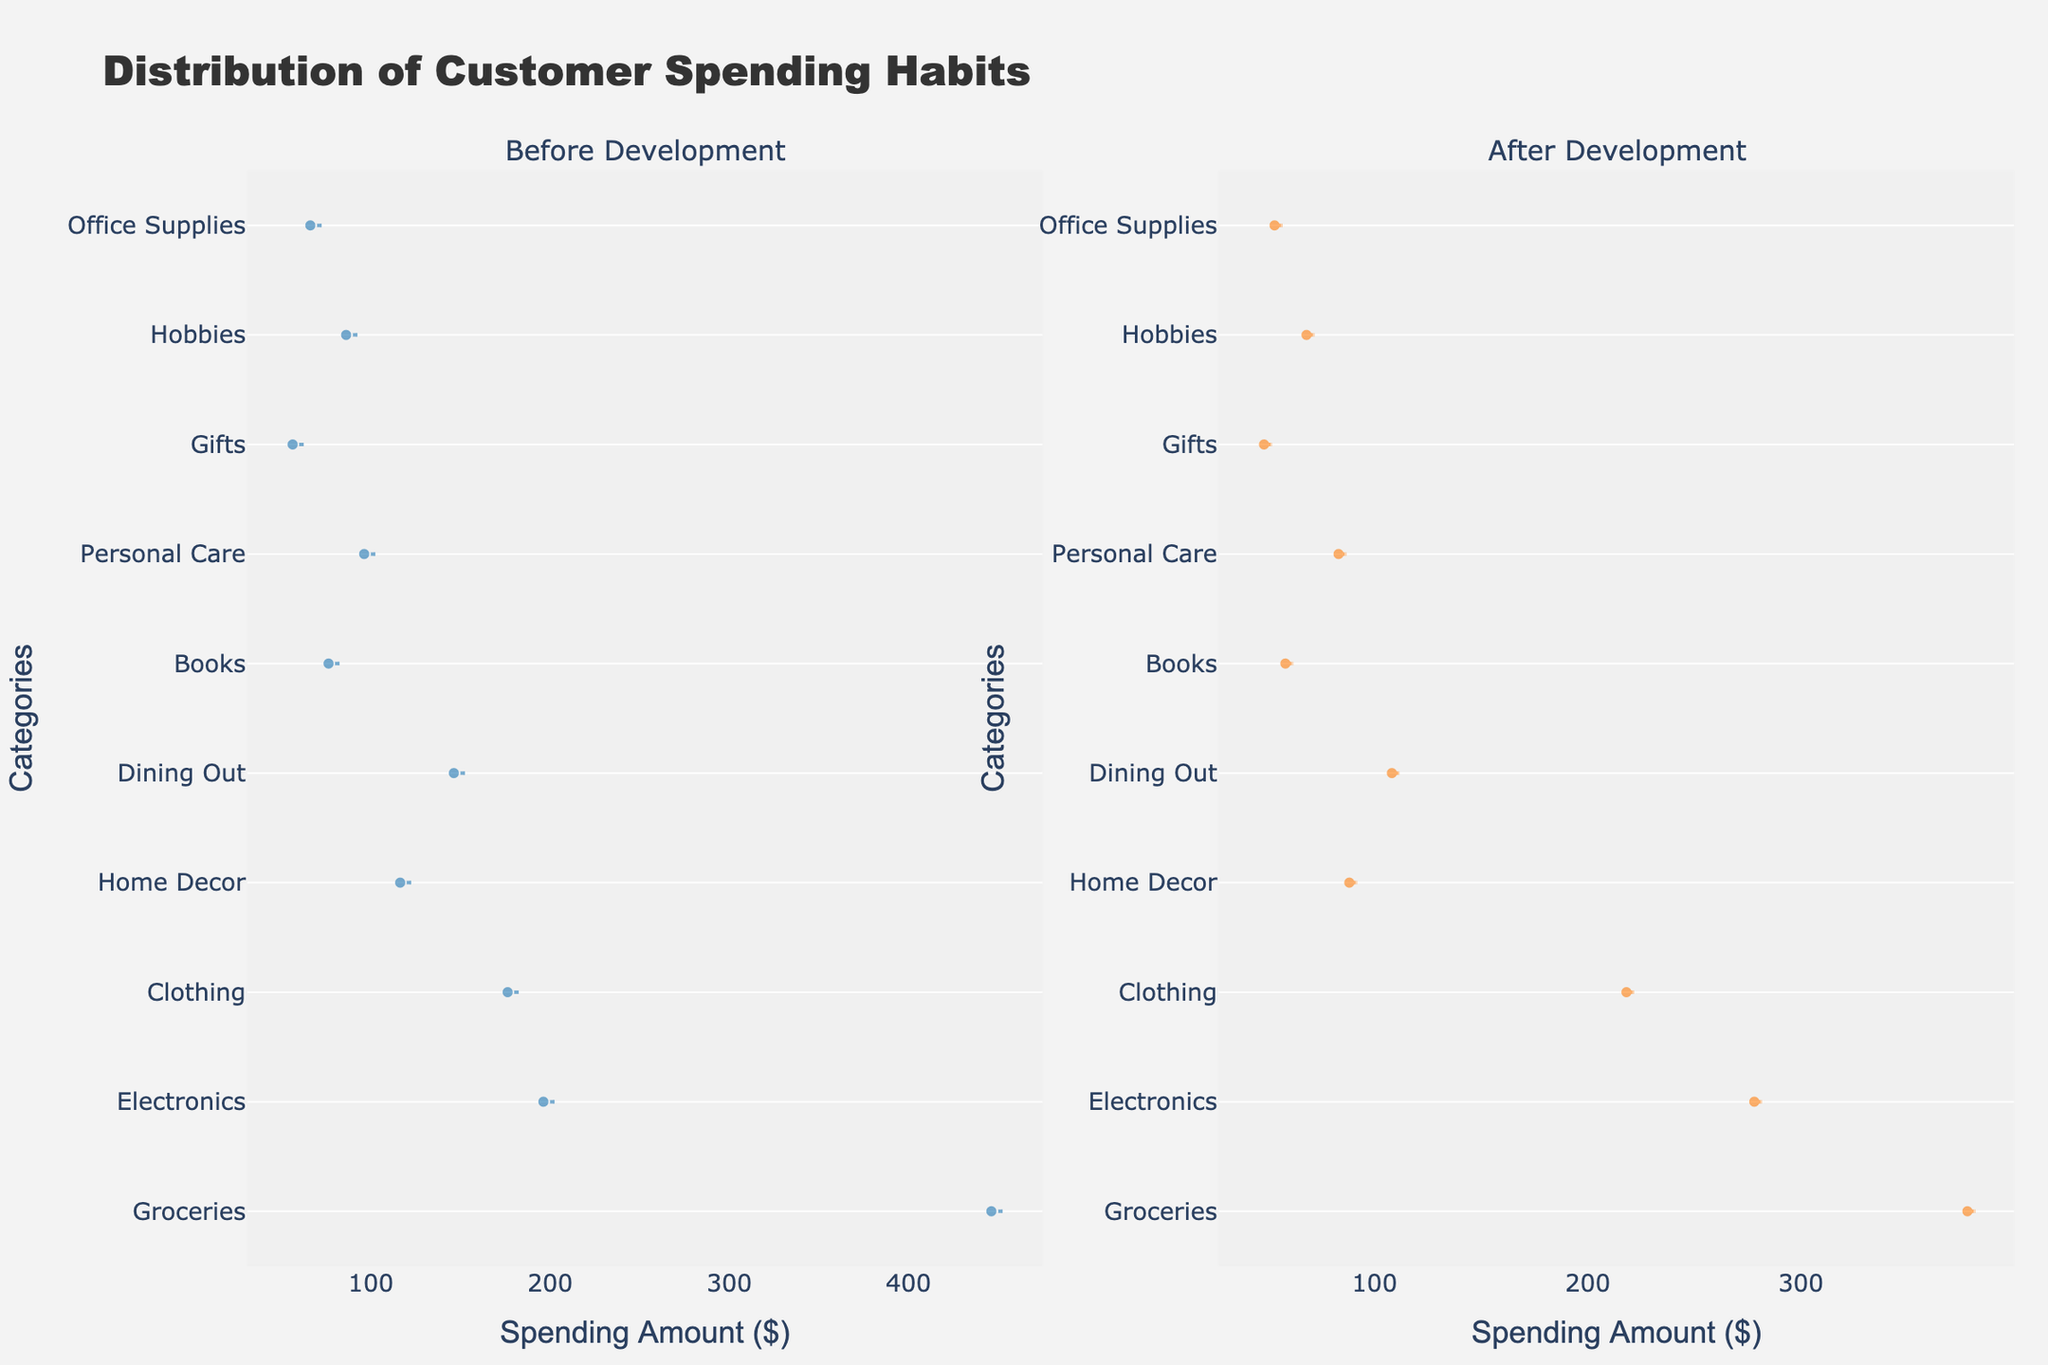What's the title of the figure? The title is generally located at the top of the plot and provides a summary of what the figure is about.
Answer: Distribution of Customer Spending Habits What are the two main periods compared in the figure? The subplot titles indicate the two periods being compared.
Answer: Before Development and After Development Which spending category has the highest decrease after the development? To determine the highest decrease, subtract the "After" spending from the "Before" spending for each category and find the maximum difference.
Answer: Groceries What category shows an increase in spending after the development? By examining the densities, the only category with a higher value in "After" compared to "Before" indicates an increase in spending.
Answer: Electronics How does the spending on "Dining Out" change after the development? Compare the "Dining Out" values in the Before and After development sections to observe the difference.
Answer: Decreases What is the spending amount for "Home Decor" Before the development? Check the value listed under the "Before" column for "Home Decor".
Answer: 120 What's the difference in spending on "Clothing" before and after development? Subtract the "After" spending from the "Before" spending for "Clothing". 220 - 180 = 40
Answer: 40 Which category has the smallest change in spending after development? Calculate the difference (absolute values) for each category and identify the smallest change.
Answer: Gifts How does the overall spending trend change after the development? Look at the general pattern of the categories' spending values and observe if they generally increase or decrease.
Answer: Decreases What unique feature signifies the central tendency in each section of the plot? Violin plots often have box plots showing median and mean lines to indicate central tendency.
Answer: Box plot with mean and median lines 